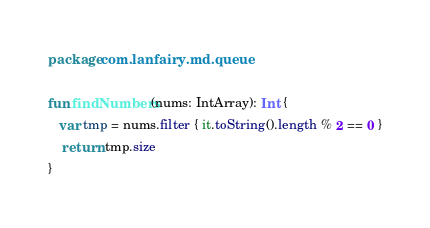<code> <loc_0><loc_0><loc_500><loc_500><_Kotlin_>package com.lanfairy.md.queue

fun findNumbers(nums: IntArray): Int {
   var tmp = nums.filter { it.toString().length % 2 == 0 }
    return tmp.size
}</code> 